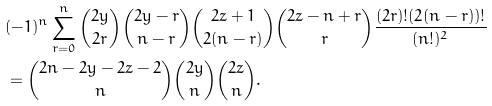Convert formula to latex. <formula><loc_0><loc_0><loc_500><loc_500>& ( - 1 ) ^ { n } \sum _ { r = 0 } ^ { n } { 2 y \choose 2 r } { 2 y - r \choose n - r } { 2 z + 1 \choose 2 ( n - r ) } { 2 z - n + r \choose r } \frac { ( 2 r ) ! ( 2 ( n - r ) ) ! } { ( n ! ) ^ { 2 } } \\ & = { 2 n - 2 y - 2 z - 2 \choose n } { 2 y \choose n } { 2 z \choose n } .</formula> 